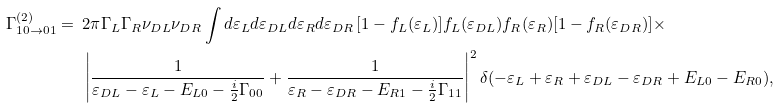Convert formula to latex. <formula><loc_0><loc_0><loc_500><loc_500>\Gamma ^ { ( 2 ) } _ { 1 0 \to 0 1 } = \ & 2 \pi \Gamma _ { L } \Gamma _ { R } \nu _ { D L } \nu _ { D R } \int d \varepsilon _ { L } d \varepsilon _ { D L } d \varepsilon _ { R } d \varepsilon _ { D R } \, [ 1 - f _ { L } ( \varepsilon _ { L } ) ] f _ { L } ( \varepsilon _ { D L } ) f _ { R } ( \varepsilon _ { R } ) [ 1 - f _ { R } ( \varepsilon _ { D R } ) ] \times \\ & \left | \frac { 1 } { \varepsilon _ { D L } - \varepsilon _ { L } - E _ { L 0 } - \frac { i } { 2 } \Gamma _ { 0 0 } } + \frac { 1 } { \varepsilon _ { R } - \varepsilon _ { D R } - E _ { R 1 } - \frac { i } { 2 } \Gamma _ { 1 1 } } \right | ^ { 2 } \delta ( - \varepsilon _ { L } + \varepsilon _ { R } + \varepsilon _ { D L } - \varepsilon _ { D R } + E _ { L 0 } - E _ { R 0 } ) ,</formula> 